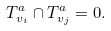<formula> <loc_0><loc_0><loc_500><loc_500>T _ { v _ { i } } ^ { a } \cap T _ { v _ { j } } ^ { a } = 0 .</formula> 